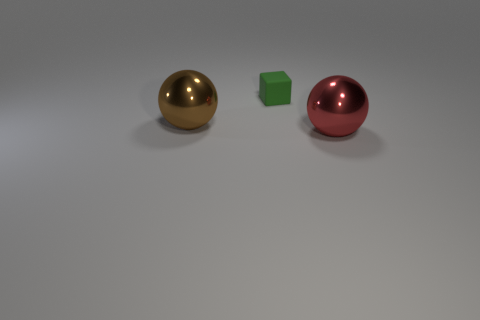If the objects depicted were part of a larger tableau, what might they represent? If these objects were part of a larger tableau, they might represent different elements within a theme of geometry and color theory. The spheres could symbolize wholeness or completeness, while the cube might stand for stability and order. Their distinct colors and shapes could signify diversity, contrast, or the uniqueness of individual elements within a cohesive group. 